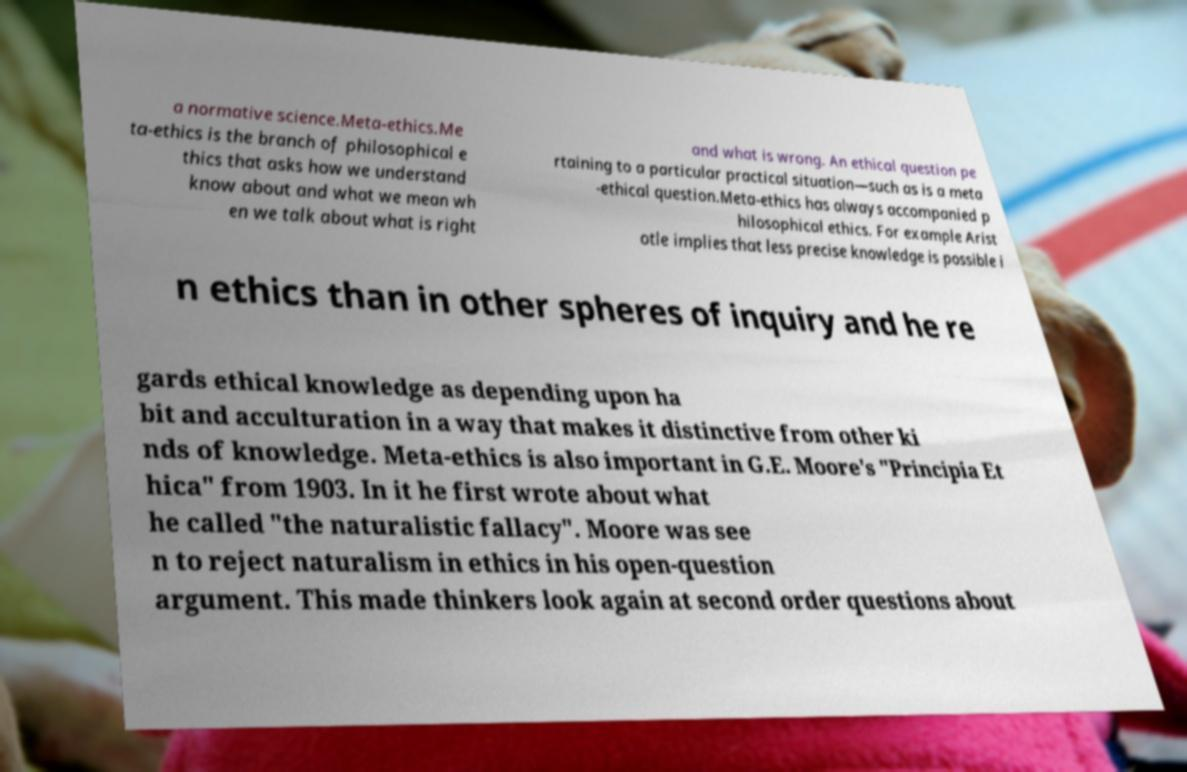I need the written content from this picture converted into text. Can you do that? a normative science.Meta-ethics.Me ta-ethics is the branch of philosophical e thics that asks how we understand know about and what we mean wh en we talk about what is right and what is wrong. An ethical question pe rtaining to a particular practical situation—such as is a meta -ethical question.Meta-ethics has always accompanied p hilosophical ethics. For example Arist otle implies that less precise knowledge is possible i n ethics than in other spheres of inquiry and he re gards ethical knowledge as depending upon ha bit and acculturation in a way that makes it distinctive from other ki nds of knowledge. Meta-ethics is also important in G.E. Moore's "Principia Et hica" from 1903. In it he first wrote about what he called "the naturalistic fallacy". Moore was see n to reject naturalism in ethics in his open-question argument. This made thinkers look again at second order questions about 